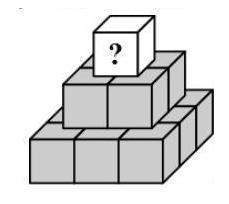Susi writes a different positive whole number on each of the 14 cubes of the pyramid (see diagram). The sum of the numbers, which she writes on the nine cubes that lie on the bottom, is 50. The number on every remaining cube is equal to the sum of the numbers of the four cubes that are directly underneath. What is the biggest number that can be written on the topmost cube?
 Answer is 118. 